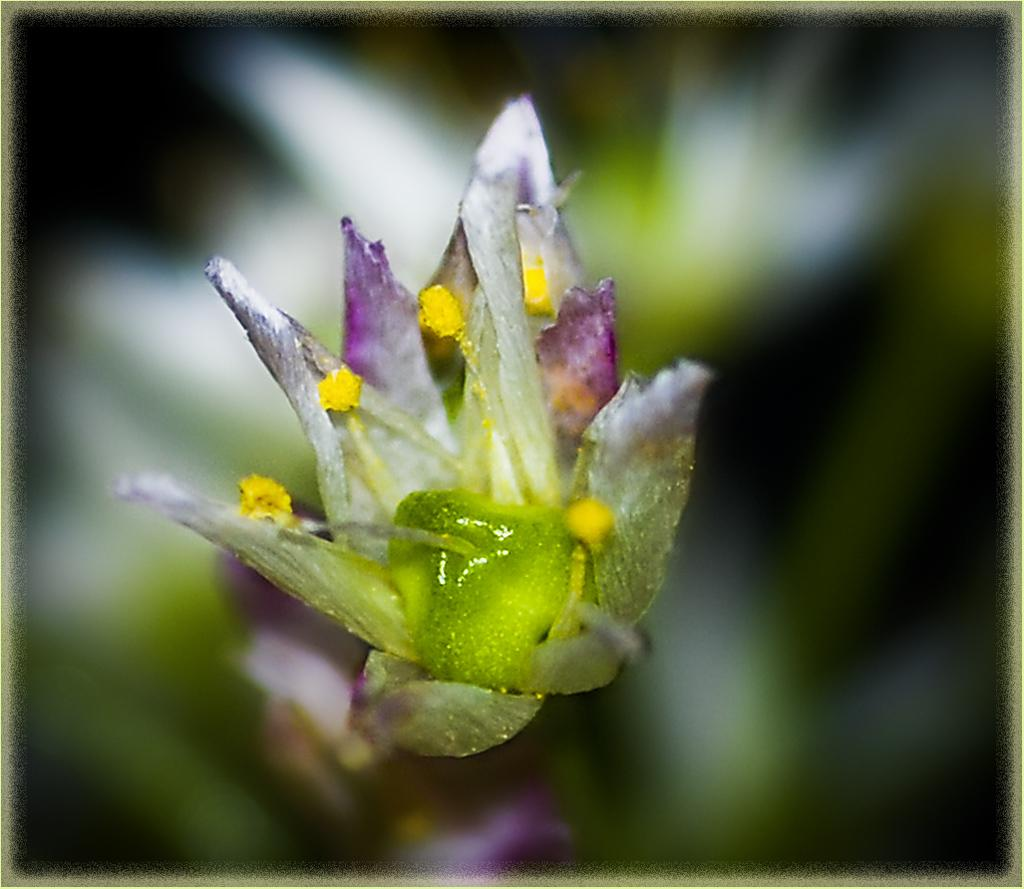What is the main subject of the image? There is a flower in the image. Can you describe the background of the image? The background of the image is blurry. What type of cork can be seen healing the wound on the flower in the image? There is no cork or wound present in the image; it features a flower with a blurry background. What type of cooking utensil is visible in the image? There are no cooking utensils present in the image; it features a flower with a blurry background. 